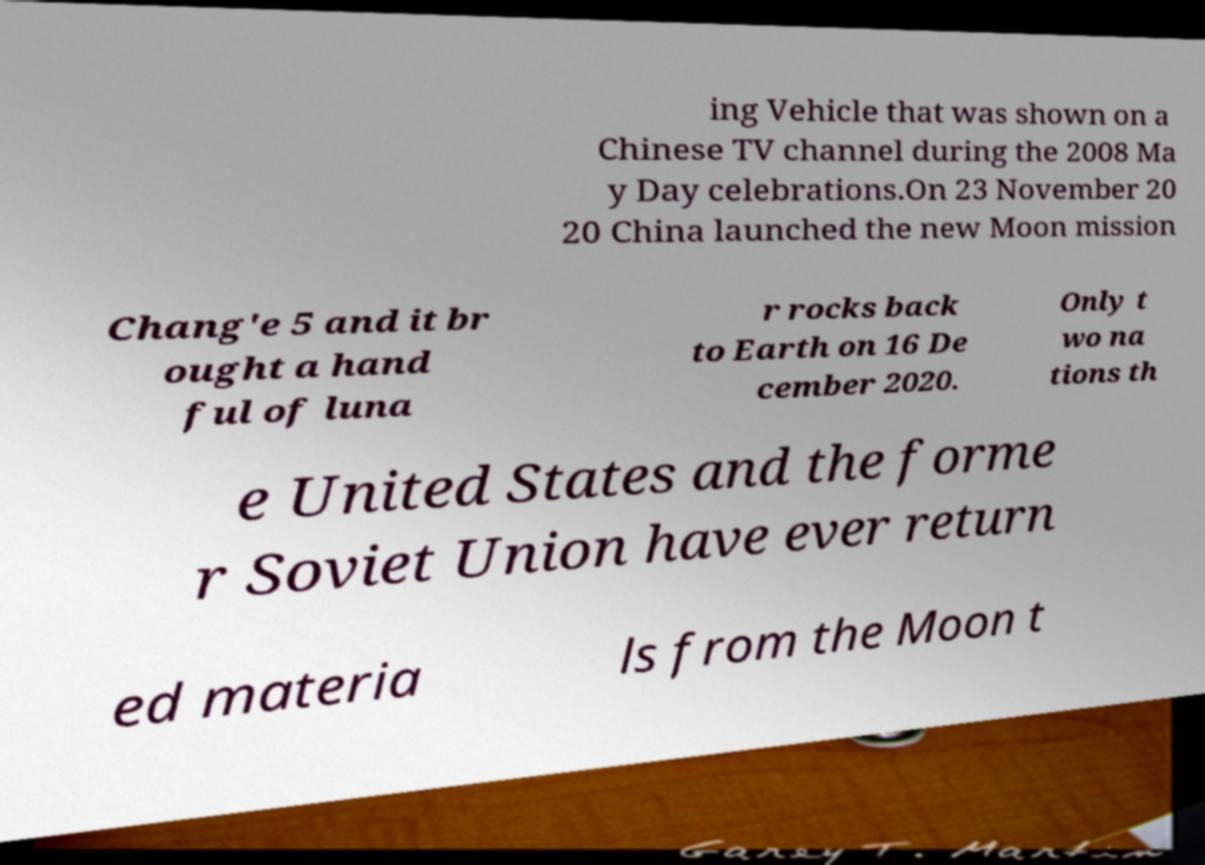For documentation purposes, I need the text within this image transcribed. Could you provide that? ing Vehicle that was shown on a Chinese TV channel during the 2008 Ma y Day celebrations.On 23 November 20 20 China launched the new Moon mission Chang'e 5 and it br ought a hand ful of luna r rocks back to Earth on 16 De cember 2020. Only t wo na tions th e United States and the forme r Soviet Union have ever return ed materia ls from the Moon t 